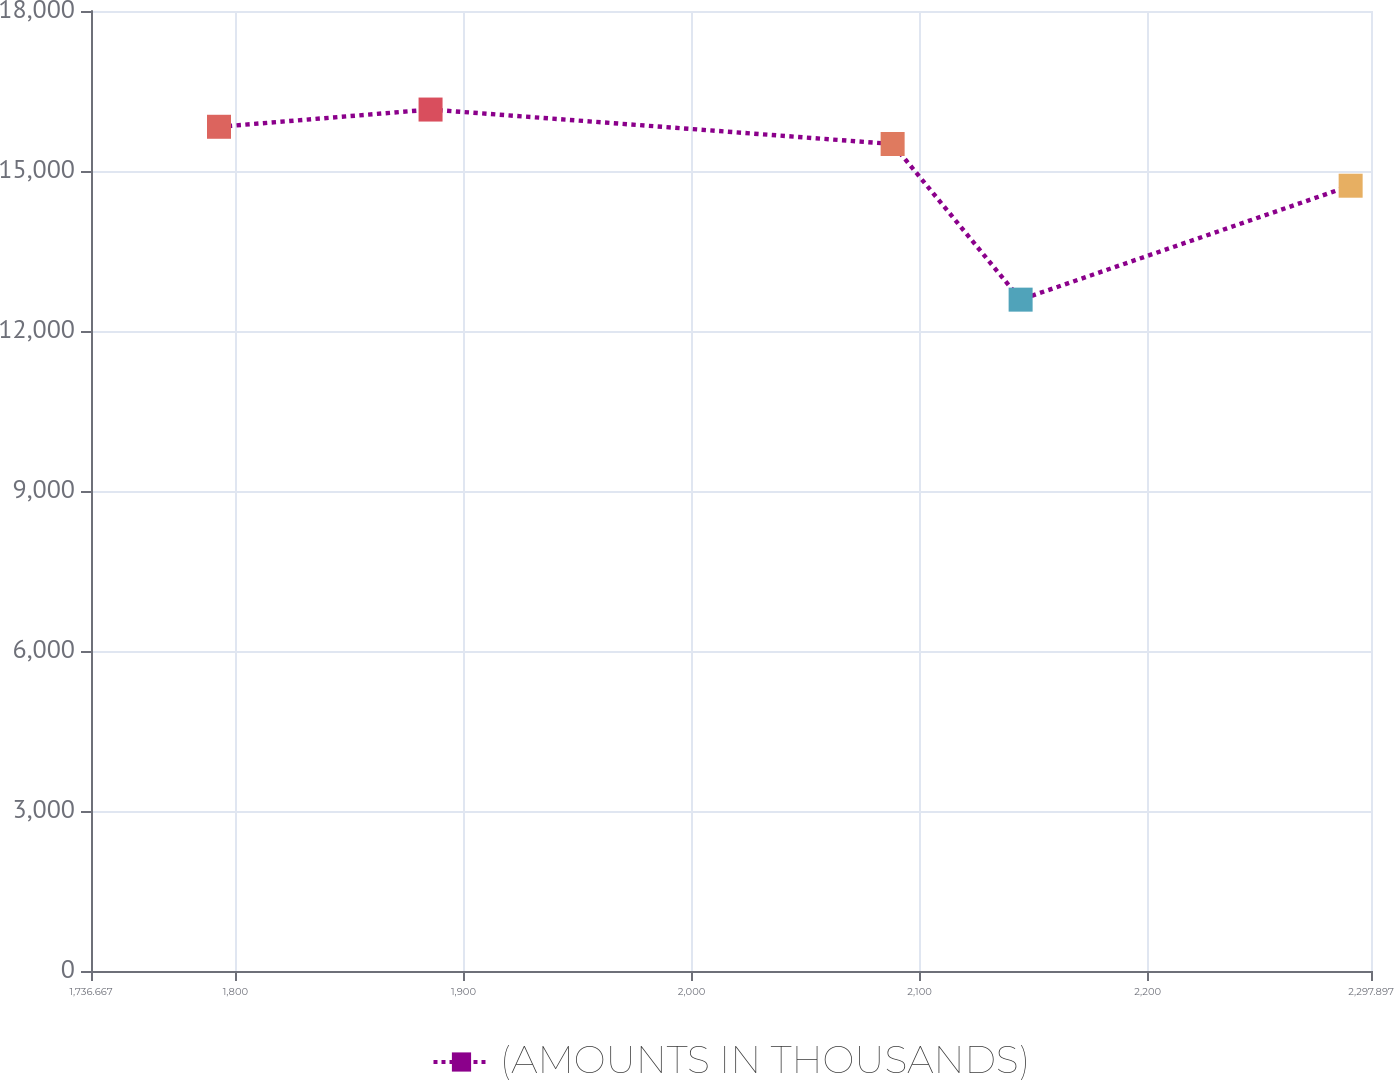Convert chart. <chart><loc_0><loc_0><loc_500><loc_500><line_chart><ecel><fcel>(AMOUNTS IN THOUSANDS)<nl><fcel>1792.79<fcel>15829.2<nl><fcel>1885.55<fcel>16152.2<nl><fcel>2088.15<fcel>15506.2<nl><fcel>2144.27<fcel>12588.1<nl><fcel>2288.97<fcel>14724.2<nl><fcel>2354.02<fcel>14008.5<nl></chart> 